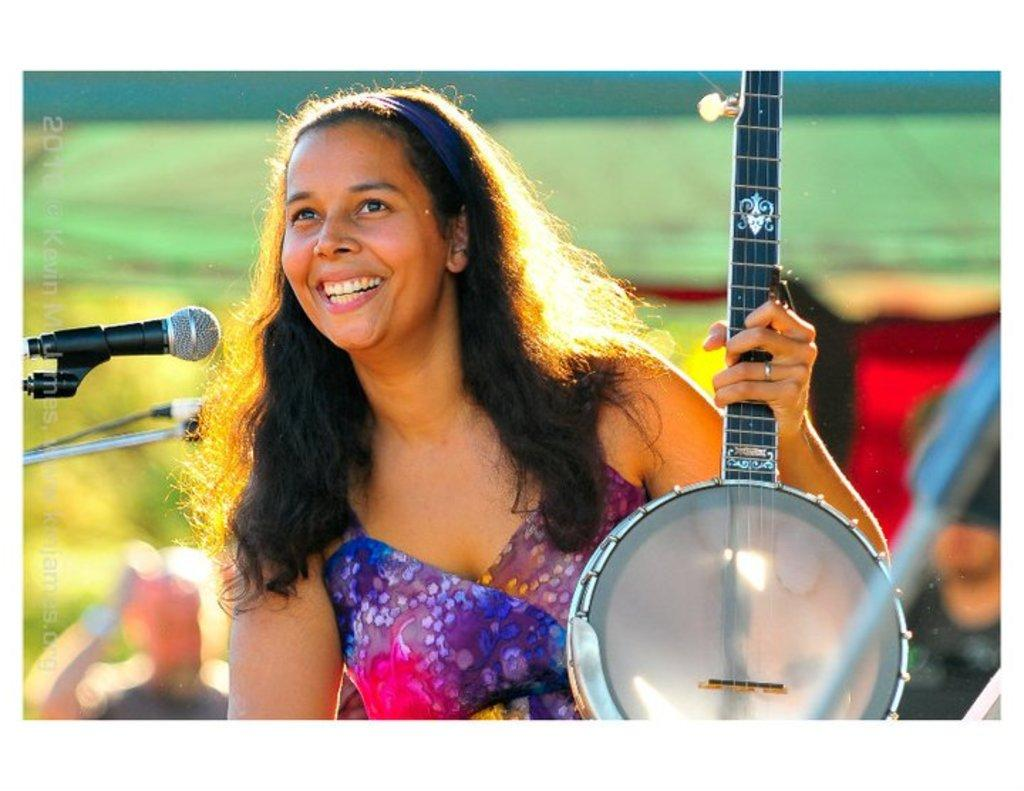What is the main subject of the image? There is a person in the image. What can be observed about the person's attire? The person is wearing clothes. What is the person holding in the image? The person is holding a musical instrument. Can you describe the object on the left side of the image? There is a mic on the left side of the image. What type of blood can be seen dripping from the person's clothes in the image? There is no blood visible in the image; the person is wearing clothes without any visible stains or drips. 